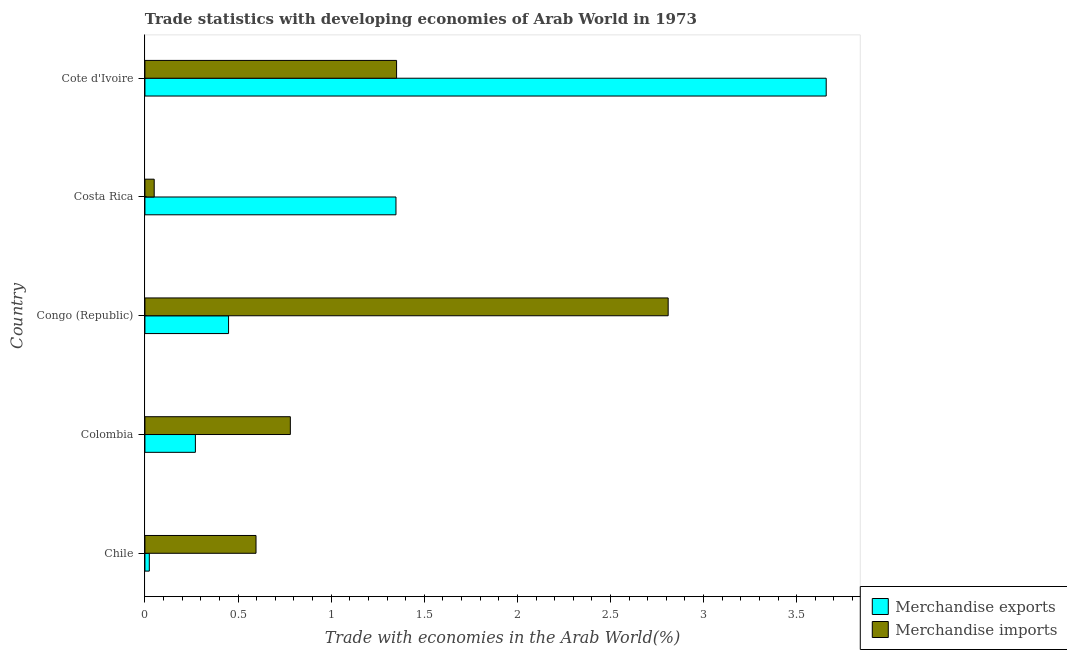How many groups of bars are there?
Your answer should be very brief. 5. Are the number of bars on each tick of the Y-axis equal?
Make the answer very short. Yes. How many bars are there on the 3rd tick from the top?
Offer a very short reply. 2. How many bars are there on the 1st tick from the bottom?
Your answer should be compact. 2. What is the label of the 1st group of bars from the top?
Give a very brief answer. Cote d'Ivoire. What is the merchandise exports in Colombia?
Your answer should be compact. 0.27. Across all countries, what is the maximum merchandise imports?
Your response must be concise. 2.81. Across all countries, what is the minimum merchandise imports?
Your response must be concise. 0.05. In which country was the merchandise imports maximum?
Your answer should be compact. Congo (Republic). What is the total merchandise exports in the graph?
Offer a very short reply. 5.75. What is the difference between the merchandise imports in Congo (Republic) and that in Cote d'Ivoire?
Make the answer very short. 1.46. What is the difference between the merchandise imports in Colombia and the merchandise exports in Cote d'Ivoire?
Keep it short and to the point. -2.88. What is the average merchandise imports per country?
Your response must be concise. 1.12. What is the difference between the merchandise imports and merchandise exports in Chile?
Keep it short and to the point. 0.57. In how many countries, is the merchandise exports greater than 0.9 %?
Offer a terse response. 2. What is the ratio of the merchandise imports in Costa Rica to that in Cote d'Ivoire?
Your response must be concise. 0.04. Is the difference between the merchandise exports in Chile and Congo (Republic) greater than the difference between the merchandise imports in Chile and Congo (Republic)?
Ensure brevity in your answer.  Yes. What is the difference between the highest and the second highest merchandise imports?
Your answer should be compact. 1.46. What is the difference between the highest and the lowest merchandise imports?
Your answer should be very brief. 2.76. What does the 1st bar from the top in Colombia represents?
Give a very brief answer. Merchandise imports. How many countries are there in the graph?
Ensure brevity in your answer.  5. Does the graph contain any zero values?
Give a very brief answer. No. How are the legend labels stacked?
Offer a very short reply. Vertical. What is the title of the graph?
Offer a very short reply. Trade statistics with developing economies of Arab World in 1973. Does "Canada" appear as one of the legend labels in the graph?
Give a very brief answer. No. What is the label or title of the X-axis?
Your response must be concise. Trade with economies in the Arab World(%). What is the label or title of the Y-axis?
Offer a very short reply. Country. What is the Trade with economies in the Arab World(%) of Merchandise exports in Chile?
Keep it short and to the point. 0.02. What is the Trade with economies in the Arab World(%) of Merchandise imports in Chile?
Keep it short and to the point. 0.6. What is the Trade with economies in the Arab World(%) of Merchandise exports in Colombia?
Keep it short and to the point. 0.27. What is the Trade with economies in the Arab World(%) in Merchandise imports in Colombia?
Your answer should be compact. 0.78. What is the Trade with economies in the Arab World(%) of Merchandise exports in Congo (Republic)?
Your answer should be very brief. 0.45. What is the Trade with economies in the Arab World(%) of Merchandise imports in Congo (Republic)?
Offer a very short reply. 2.81. What is the Trade with economies in the Arab World(%) in Merchandise exports in Costa Rica?
Provide a short and direct response. 1.35. What is the Trade with economies in the Arab World(%) in Merchandise imports in Costa Rica?
Ensure brevity in your answer.  0.05. What is the Trade with economies in the Arab World(%) in Merchandise exports in Cote d'Ivoire?
Offer a terse response. 3.66. What is the Trade with economies in the Arab World(%) in Merchandise imports in Cote d'Ivoire?
Make the answer very short. 1.35. Across all countries, what is the maximum Trade with economies in the Arab World(%) in Merchandise exports?
Offer a terse response. 3.66. Across all countries, what is the maximum Trade with economies in the Arab World(%) in Merchandise imports?
Make the answer very short. 2.81. Across all countries, what is the minimum Trade with economies in the Arab World(%) in Merchandise exports?
Provide a succinct answer. 0.02. Across all countries, what is the minimum Trade with economies in the Arab World(%) in Merchandise imports?
Your answer should be very brief. 0.05. What is the total Trade with economies in the Arab World(%) of Merchandise exports in the graph?
Ensure brevity in your answer.  5.75. What is the total Trade with economies in the Arab World(%) of Merchandise imports in the graph?
Give a very brief answer. 5.59. What is the difference between the Trade with economies in the Arab World(%) in Merchandise exports in Chile and that in Colombia?
Offer a terse response. -0.25. What is the difference between the Trade with economies in the Arab World(%) in Merchandise imports in Chile and that in Colombia?
Ensure brevity in your answer.  -0.18. What is the difference between the Trade with economies in the Arab World(%) of Merchandise exports in Chile and that in Congo (Republic)?
Your response must be concise. -0.43. What is the difference between the Trade with economies in the Arab World(%) in Merchandise imports in Chile and that in Congo (Republic)?
Offer a very short reply. -2.21. What is the difference between the Trade with economies in the Arab World(%) in Merchandise exports in Chile and that in Costa Rica?
Your answer should be very brief. -1.32. What is the difference between the Trade with economies in the Arab World(%) in Merchandise imports in Chile and that in Costa Rica?
Ensure brevity in your answer.  0.55. What is the difference between the Trade with economies in the Arab World(%) in Merchandise exports in Chile and that in Cote d'Ivoire?
Keep it short and to the point. -3.63. What is the difference between the Trade with economies in the Arab World(%) of Merchandise imports in Chile and that in Cote d'Ivoire?
Provide a succinct answer. -0.75. What is the difference between the Trade with economies in the Arab World(%) in Merchandise exports in Colombia and that in Congo (Republic)?
Your answer should be very brief. -0.18. What is the difference between the Trade with economies in the Arab World(%) of Merchandise imports in Colombia and that in Congo (Republic)?
Your answer should be compact. -2.03. What is the difference between the Trade with economies in the Arab World(%) of Merchandise exports in Colombia and that in Costa Rica?
Give a very brief answer. -1.08. What is the difference between the Trade with economies in the Arab World(%) of Merchandise imports in Colombia and that in Costa Rica?
Your response must be concise. 0.73. What is the difference between the Trade with economies in the Arab World(%) of Merchandise exports in Colombia and that in Cote d'Ivoire?
Your answer should be very brief. -3.39. What is the difference between the Trade with economies in the Arab World(%) in Merchandise imports in Colombia and that in Cote d'Ivoire?
Provide a succinct answer. -0.57. What is the difference between the Trade with economies in the Arab World(%) of Merchandise exports in Congo (Republic) and that in Costa Rica?
Offer a terse response. -0.9. What is the difference between the Trade with economies in the Arab World(%) in Merchandise imports in Congo (Republic) and that in Costa Rica?
Your response must be concise. 2.76. What is the difference between the Trade with economies in the Arab World(%) of Merchandise exports in Congo (Republic) and that in Cote d'Ivoire?
Your answer should be very brief. -3.21. What is the difference between the Trade with economies in the Arab World(%) of Merchandise imports in Congo (Republic) and that in Cote d'Ivoire?
Provide a succinct answer. 1.46. What is the difference between the Trade with economies in the Arab World(%) in Merchandise exports in Costa Rica and that in Cote d'Ivoire?
Your answer should be very brief. -2.31. What is the difference between the Trade with economies in the Arab World(%) in Merchandise imports in Costa Rica and that in Cote d'Ivoire?
Offer a very short reply. -1.3. What is the difference between the Trade with economies in the Arab World(%) of Merchandise exports in Chile and the Trade with economies in the Arab World(%) of Merchandise imports in Colombia?
Your response must be concise. -0.76. What is the difference between the Trade with economies in the Arab World(%) of Merchandise exports in Chile and the Trade with economies in the Arab World(%) of Merchandise imports in Congo (Republic)?
Ensure brevity in your answer.  -2.79. What is the difference between the Trade with economies in the Arab World(%) of Merchandise exports in Chile and the Trade with economies in the Arab World(%) of Merchandise imports in Costa Rica?
Your answer should be very brief. -0.03. What is the difference between the Trade with economies in the Arab World(%) of Merchandise exports in Chile and the Trade with economies in the Arab World(%) of Merchandise imports in Cote d'Ivoire?
Ensure brevity in your answer.  -1.33. What is the difference between the Trade with economies in the Arab World(%) of Merchandise exports in Colombia and the Trade with economies in the Arab World(%) of Merchandise imports in Congo (Republic)?
Ensure brevity in your answer.  -2.54. What is the difference between the Trade with economies in the Arab World(%) of Merchandise exports in Colombia and the Trade with economies in the Arab World(%) of Merchandise imports in Costa Rica?
Offer a very short reply. 0.22. What is the difference between the Trade with economies in the Arab World(%) in Merchandise exports in Colombia and the Trade with economies in the Arab World(%) in Merchandise imports in Cote d'Ivoire?
Keep it short and to the point. -1.08. What is the difference between the Trade with economies in the Arab World(%) of Merchandise exports in Congo (Republic) and the Trade with economies in the Arab World(%) of Merchandise imports in Costa Rica?
Offer a very short reply. 0.4. What is the difference between the Trade with economies in the Arab World(%) of Merchandise exports in Congo (Republic) and the Trade with economies in the Arab World(%) of Merchandise imports in Cote d'Ivoire?
Your response must be concise. -0.9. What is the difference between the Trade with economies in the Arab World(%) of Merchandise exports in Costa Rica and the Trade with economies in the Arab World(%) of Merchandise imports in Cote d'Ivoire?
Your answer should be very brief. -0. What is the average Trade with economies in the Arab World(%) of Merchandise exports per country?
Offer a very short reply. 1.15. What is the average Trade with economies in the Arab World(%) in Merchandise imports per country?
Your answer should be very brief. 1.12. What is the difference between the Trade with economies in the Arab World(%) of Merchandise exports and Trade with economies in the Arab World(%) of Merchandise imports in Chile?
Your response must be concise. -0.57. What is the difference between the Trade with economies in the Arab World(%) in Merchandise exports and Trade with economies in the Arab World(%) in Merchandise imports in Colombia?
Your answer should be compact. -0.51. What is the difference between the Trade with economies in the Arab World(%) of Merchandise exports and Trade with economies in the Arab World(%) of Merchandise imports in Congo (Republic)?
Make the answer very short. -2.36. What is the difference between the Trade with economies in the Arab World(%) in Merchandise exports and Trade with economies in the Arab World(%) in Merchandise imports in Costa Rica?
Keep it short and to the point. 1.3. What is the difference between the Trade with economies in the Arab World(%) in Merchandise exports and Trade with economies in the Arab World(%) in Merchandise imports in Cote d'Ivoire?
Give a very brief answer. 2.31. What is the ratio of the Trade with economies in the Arab World(%) in Merchandise exports in Chile to that in Colombia?
Your answer should be compact. 0.09. What is the ratio of the Trade with economies in the Arab World(%) of Merchandise imports in Chile to that in Colombia?
Provide a short and direct response. 0.76. What is the ratio of the Trade with economies in the Arab World(%) of Merchandise exports in Chile to that in Congo (Republic)?
Provide a succinct answer. 0.05. What is the ratio of the Trade with economies in the Arab World(%) in Merchandise imports in Chile to that in Congo (Republic)?
Make the answer very short. 0.21. What is the ratio of the Trade with economies in the Arab World(%) of Merchandise exports in Chile to that in Costa Rica?
Give a very brief answer. 0.02. What is the ratio of the Trade with economies in the Arab World(%) of Merchandise imports in Chile to that in Costa Rica?
Provide a short and direct response. 11.96. What is the ratio of the Trade with economies in the Arab World(%) in Merchandise exports in Chile to that in Cote d'Ivoire?
Give a very brief answer. 0.01. What is the ratio of the Trade with economies in the Arab World(%) of Merchandise imports in Chile to that in Cote d'Ivoire?
Your response must be concise. 0.44. What is the ratio of the Trade with economies in the Arab World(%) in Merchandise exports in Colombia to that in Congo (Republic)?
Keep it short and to the point. 0.6. What is the ratio of the Trade with economies in the Arab World(%) of Merchandise imports in Colombia to that in Congo (Republic)?
Offer a very short reply. 0.28. What is the ratio of the Trade with economies in the Arab World(%) of Merchandise exports in Colombia to that in Costa Rica?
Provide a short and direct response. 0.2. What is the ratio of the Trade with economies in the Arab World(%) of Merchandise imports in Colombia to that in Costa Rica?
Provide a short and direct response. 15.65. What is the ratio of the Trade with economies in the Arab World(%) of Merchandise exports in Colombia to that in Cote d'Ivoire?
Offer a terse response. 0.07. What is the ratio of the Trade with economies in the Arab World(%) in Merchandise imports in Colombia to that in Cote d'Ivoire?
Offer a very short reply. 0.58. What is the ratio of the Trade with economies in the Arab World(%) in Merchandise exports in Congo (Republic) to that in Costa Rica?
Keep it short and to the point. 0.33. What is the ratio of the Trade with economies in the Arab World(%) of Merchandise imports in Congo (Republic) to that in Costa Rica?
Offer a terse response. 56.32. What is the ratio of the Trade with economies in the Arab World(%) of Merchandise exports in Congo (Republic) to that in Cote d'Ivoire?
Provide a short and direct response. 0.12. What is the ratio of the Trade with economies in the Arab World(%) of Merchandise imports in Congo (Republic) to that in Cote d'Ivoire?
Your answer should be very brief. 2.08. What is the ratio of the Trade with economies in the Arab World(%) in Merchandise exports in Costa Rica to that in Cote d'Ivoire?
Offer a very short reply. 0.37. What is the ratio of the Trade with economies in the Arab World(%) in Merchandise imports in Costa Rica to that in Cote d'Ivoire?
Keep it short and to the point. 0.04. What is the difference between the highest and the second highest Trade with economies in the Arab World(%) in Merchandise exports?
Make the answer very short. 2.31. What is the difference between the highest and the second highest Trade with economies in the Arab World(%) in Merchandise imports?
Your response must be concise. 1.46. What is the difference between the highest and the lowest Trade with economies in the Arab World(%) of Merchandise exports?
Your answer should be very brief. 3.63. What is the difference between the highest and the lowest Trade with economies in the Arab World(%) in Merchandise imports?
Your answer should be compact. 2.76. 